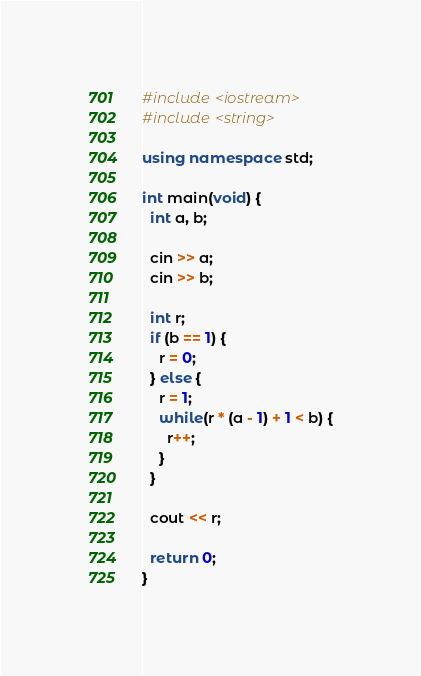<code> <loc_0><loc_0><loc_500><loc_500><_C++_>#include <iostream>
#include <string>

using namespace std;

int main(void) {
  int a, b;

  cin >> a;
  cin >> b;

  int r;
  if (b == 1) {
    r = 0;
  } else {
    r = 1;
    while(r * (a - 1) + 1 < b) {
      r++;
    }
  }

  cout << r;

  return 0;
}</code> 